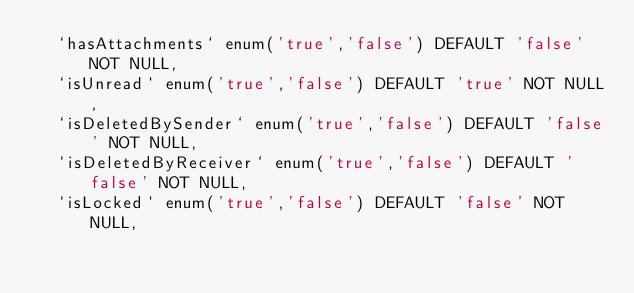<code> <loc_0><loc_0><loc_500><loc_500><_SQL_>  `hasAttachments` enum('true','false') DEFAULT 'false' NOT NULL,
  `isUnread` enum('true','false') DEFAULT 'true' NOT NULL,
  `isDeletedBySender` enum('true','false') DEFAULT 'false' NOT NULL,
  `isDeletedByReceiver` enum('true','false') DEFAULT 'false' NOT NULL,
  `isLocked` enum('true','false') DEFAULT 'false' NOT NULL,</code> 